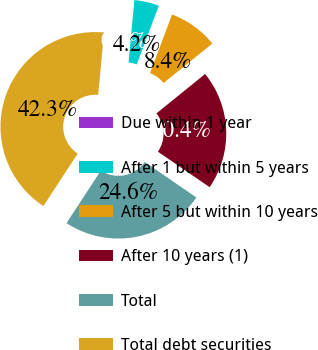Convert chart. <chart><loc_0><loc_0><loc_500><loc_500><pie_chart><fcel>Due within 1 year<fcel>After 1 but within 5 years<fcel>After 5 but within 10 years<fcel>After 10 years (1)<fcel>Total<fcel>Total debt securities<nl><fcel>0.0%<fcel>4.23%<fcel>8.45%<fcel>20.41%<fcel>24.64%<fcel>42.27%<nl></chart> 